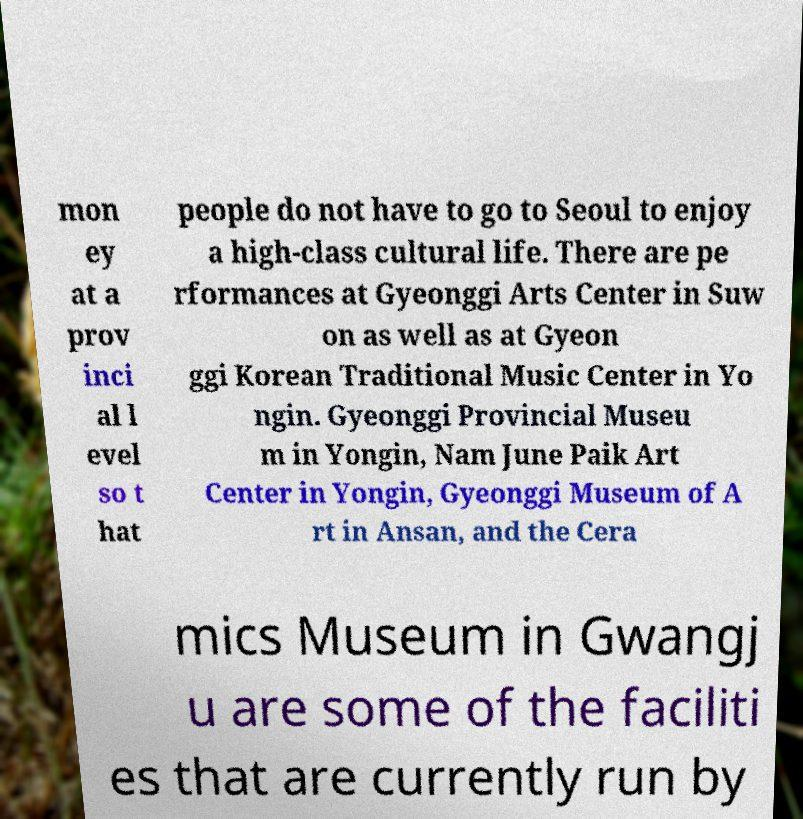Please read and relay the text visible in this image. What does it say? mon ey at a prov inci al l evel so t hat people do not have to go to Seoul to enjoy a high-class cultural life. There are pe rformances at Gyeonggi Arts Center in Suw on as well as at Gyeon ggi Korean Traditional Music Center in Yo ngin. Gyeonggi Provincial Museu m in Yongin, Nam June Paik Art Center in Yongin, Gyeonggi Museum of A rt in Ansan, and the Cera mics Museum in Gwangj u are some of the faciliti es that are currently run by 